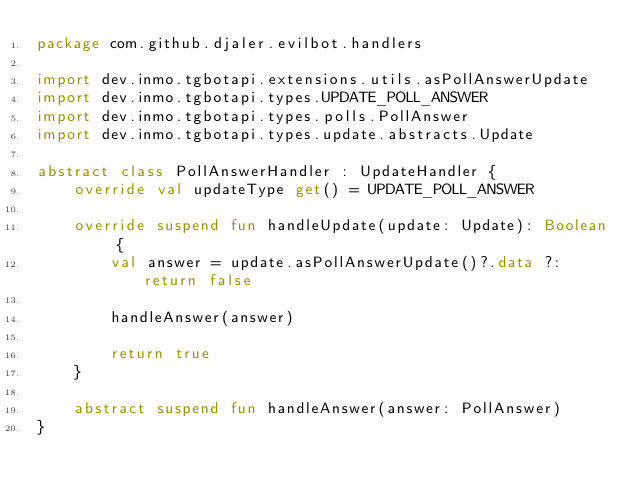<code> <loc_0><loc_0><loc_500><loc_500><_Kotlin_>package com.github.djaler.evilbot.handlers

import dev.inmo.tgbotapi.extensions.utils.asPollAnswerUpdate
import dev.inmo.tgbotapi.types.UPDATE_POLL_ANSWER
import dev.inmo.tgbotapi.types.polls.PollAnswer
import dev.inmo.tgbotapi.types.update.abstracts.Update

abstract class PollAnswerHandler : UpdateHandler {
    override val updateType get() = UPDATE_POLL_ANSWER

    override suspend fun handleUpdate(update: Update): Boolean {
        val answer = update.asPollAnswerUpdate()?.data ?: return false

        handleAnswer(answer)

        return true
    }

    abstract suspend fun handleAnswer(answer: PollAnswer)
}</code> 